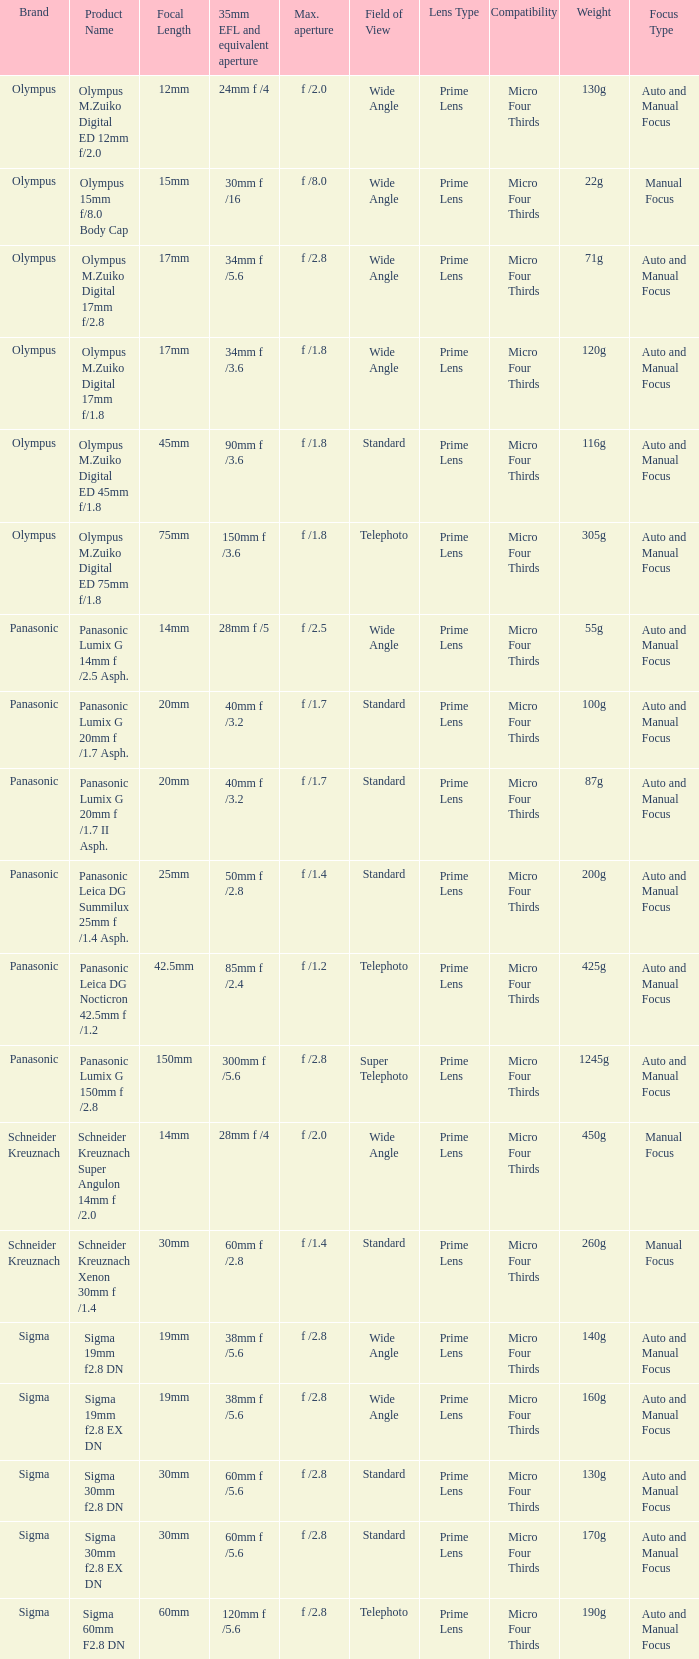What is the 35mm EFL and the equivalent aperture of the lens(es) with a maximum aperture of f /2.5? 28mm f /5. 